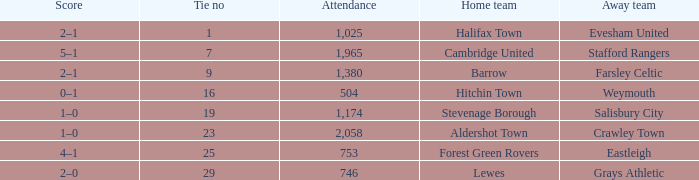How many attended tie number 19? 1174.0. 